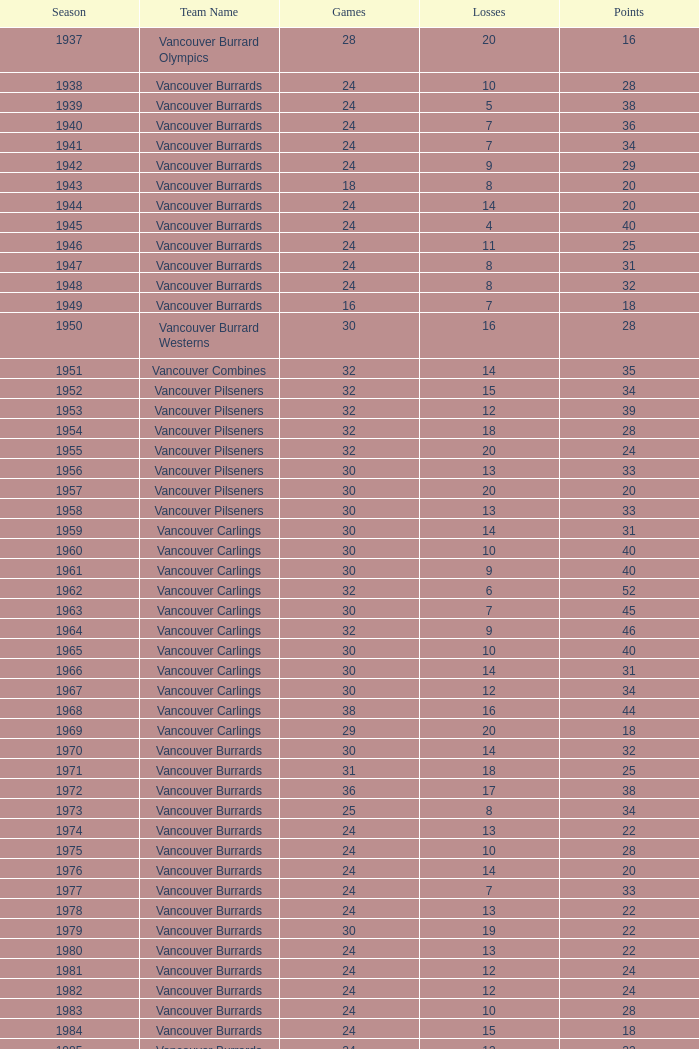How many games featured more than 20 points in the 1976 season? 0.0. 